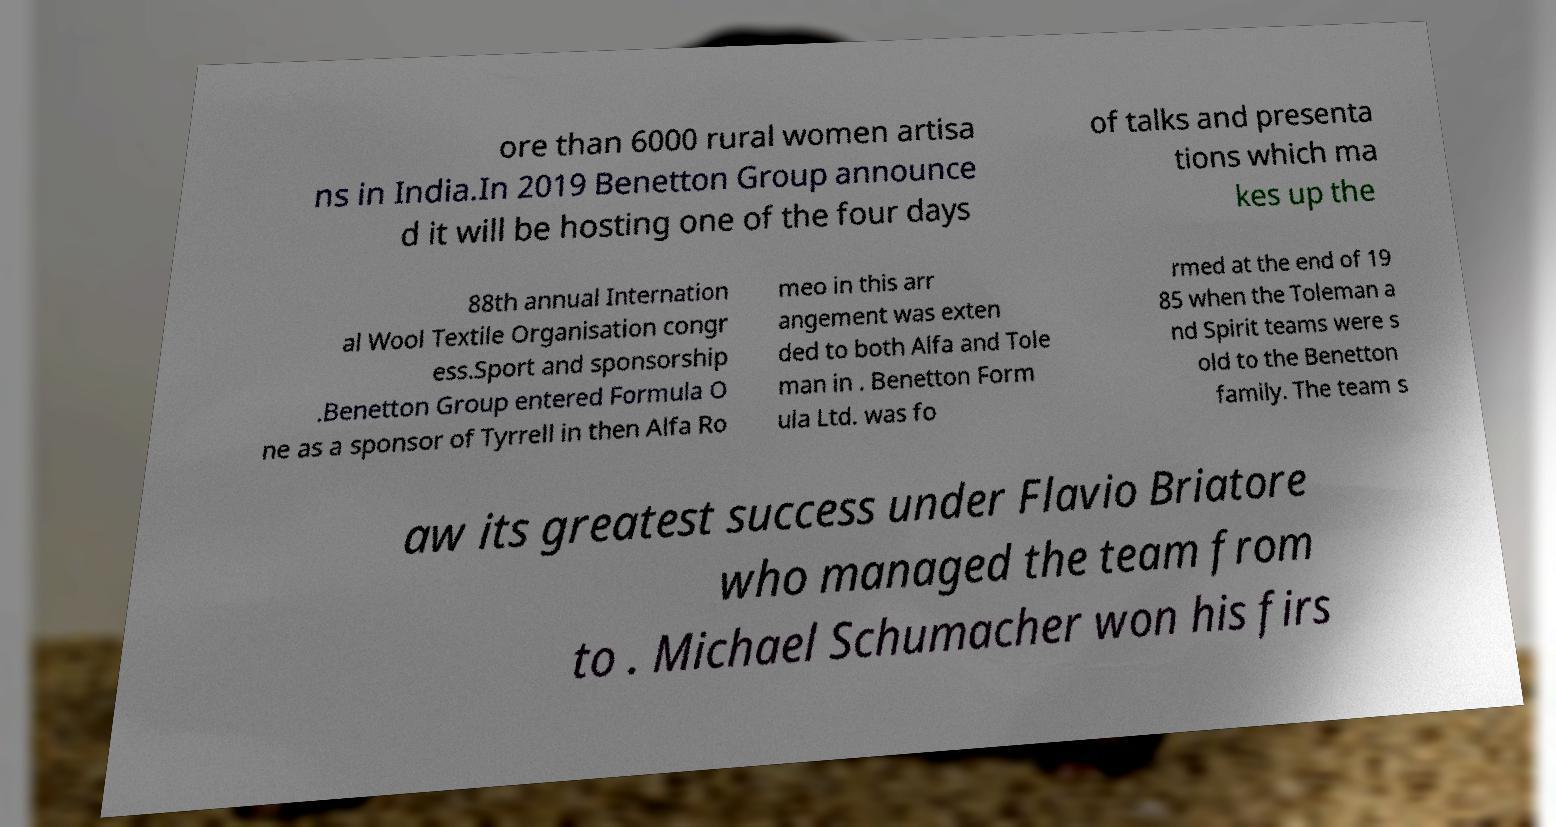For documentation purposes, I need the text within this image transcribed. Could you provide that? ore than 6000 rural women artisa ns in India.In 2019 Benetton Group announce d it will be hosting one of the four days of talks and presenta tions which ma kes up the 88th annual Internation al Wool Textile Organisation congr ess.Sport and sponsorship .Benetton Group entered Formula O ne as a sponsor of Tyrrell in then Alfa Ro meo in this arr angement was exten ded to both Alfa and Tole man in . Benetton Form ula Ltd. was fo rmed at the end of 19 85 when the Toleman a nd Spirit teams were s old to the Benetton family. The team s aw its greatest success under Flavio Briatore who managed the team from to . Michael Schumacher won his firs 